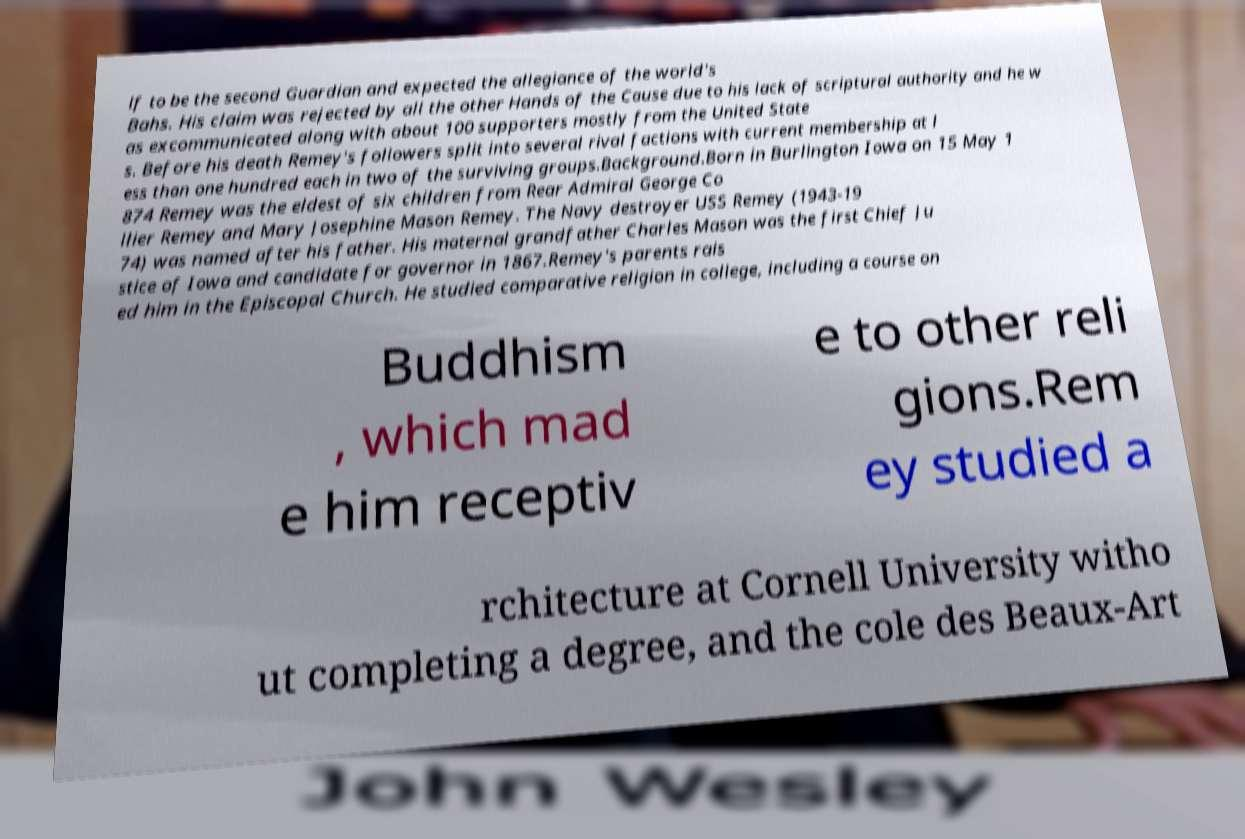Please read and relay the text visible in this image. What does it say? lf to be the second Guardian and expected the allegiance of the world's Bahs. His claim was rejected by all the other Hands of the Cause due to his lack of scriptural authority and he w as excommunicated along with about 100 supporters mostly from the United State s. Before his death Remey's followers split into several rival factions with current membership at l ess than one hundred each in two of the surviving groups.Background.Born in Burlington Iowa on 15 May 1 874 Remey was the eldest of six children from Rear Admiral George Co llier Remey and Mary Josephine Mason Remey. The Navy destroyer USS Remey (1943-19 74) was named after his father. His maternal grandfather Charles Mason was the first Chief Ju stice of Iowa and candidate for governor in 1867.Remey's parents rais ed him in the Episcopal Church. He studied comparative religion in college, including a course on Buddhism , which mad e him receptiv e to other reli gions.Rem ey studied a rchitecture at Cornell University witho ut completing a degree, and the cole des Beaux-Art 